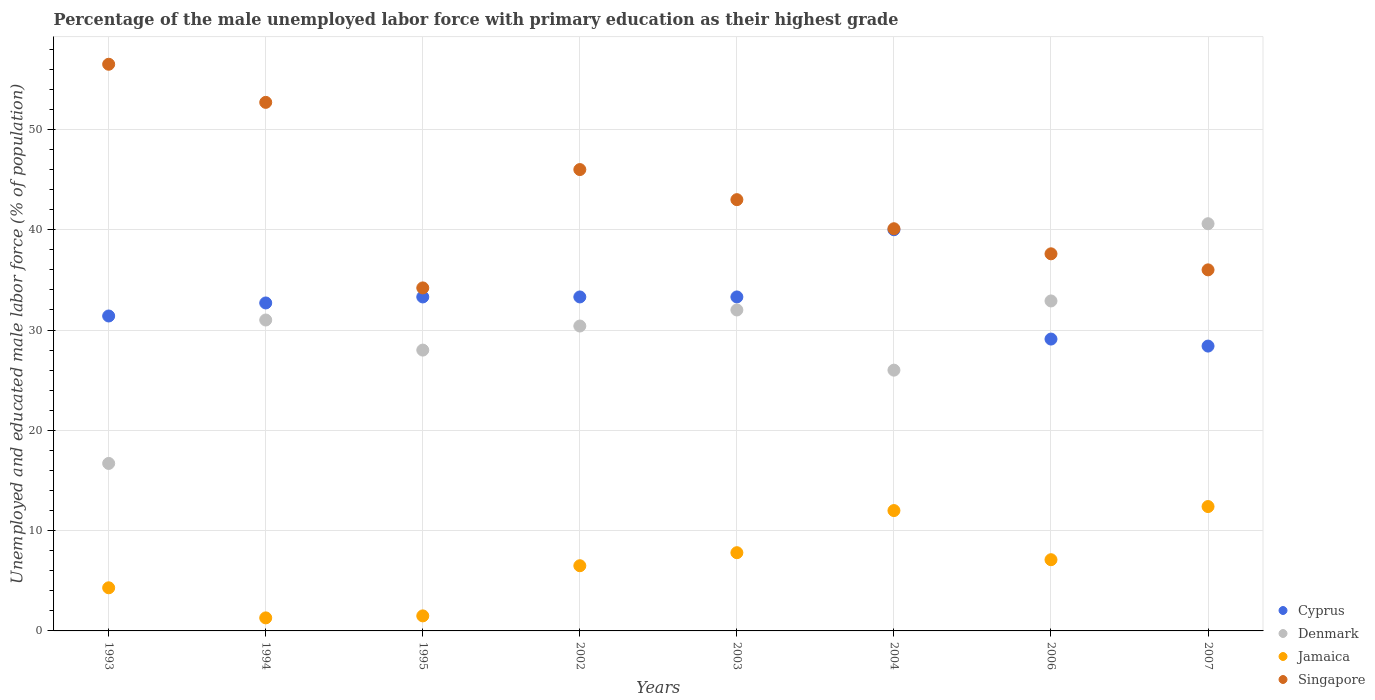How many different coloured dotlines are there?
Provide a succinct answer. 4. What is the percentage of the unemployed male labor force with primary education in Cyprus in 2006?
Your response must be concise. 29.1. Across all years, what is the maximum percentage of the unemployed male labor force with primary education in Cyprus?
Keep it short and to the point. 40. Across all years, what is the minimum percentage of the unemployed male labor force with primary education in Cyprus?
Your response must be concise. 28.4. In which year was the percentage of the unemployed male labor force with primary education in Singapore maximum?
Offer a very short reply. 1993. What is the total percentage of the unemployed male labor force with primary education in Singapore in the graph?
Ensure brevity in your answer.  346.1. What is the difference between the percentage of the unemployed male labor force with primary education in Jamaica in 1994 and that in 2006?
Keep it short and to the point. -5.8. What is the difference between the percentage of the unemployed male labor force with primary education in Jamaica in 2006 and the percentage of the unemployed male labor force with primary education in Singapore in 2004?
Make the answer very short. -33. What is the average percentage of the unemployed male labor force with primary education in Denmark per year?
Your answer should be compact. 29.7. In the year 1993, what is the difference between the percentage of the unemployed male labor force with primary education in Denmark and percentage of the unemployed male labor force with primary education in Cyprus?
Keep it short and to the point. -14.7. What is the ratio of the percentage of the unemployed male labor force with primary education in Denmark in 1995 to that in 2004?
Ensure brevity in your answer.  1.08. What is the difference between the highest and the second highest percentage of the unemployed male labor force with primary education in Cyprus?
Make the answer very short. 6.7. What is the difference between the highest and the lowest percentage of the unemployed male labor force with primary education in Denmark?
Provide a succinct answer. 23.9. Is the sum of the percentage of the unemployed male labor force with primary education in Denmark in 2002 and 2003 greater than the maximum percentage of the unemployed male labor force with primary education in Cyprus across all years?
Provide a short and direct response. Yes. Is it the case that in every year, the sum of the percentage of the unemployed male labor force with primary education in Jamaica and percentage of the unemployed male labor force with primary education in Denmark  is greater than the sum of percentage of the unemployed male labor force with primary education in Singapore and percentage of the unemployed male labor force with primary education in Cyprus?
Your answer should be compact. No. Is the percentage of the unemployed male labor force with primary education in Cyprus strictly less than the percentage of the unemployed male labor force with primary education in Denmark over the years?
Offer a very short reply. No. How many years are there in the graph?
Your answer should be compact. 8. Are the values on the major ticks of Y-axis written in scientific E-notation?
Provide a succinct answer. No. Does the graph contain any zero values?
Your answer should be compact. No. Does the graph contain grids?
Your answer should be compact. Yes. How many legend labels are there?
Offer a very short reply. 4. How are the legend labels stacked?
Provide a short and direct response. Vertical. What is the title of the graph?
Keep it short and to the point. Percentage of the male unemployed labor force with primary education as their highest grade. What is the label or title of the Y-axis?
Ensure brevity in your answer.  Unemployed and educated male labor force (% of population). What is the Unemployed and educated male labor force (% of population) of Cyprus in 1993?
Make the answer very short. 31.4. What is the Unemployed and educated male labor force (% of population) of Denmark in 1993?
Your response must be concise. 16.7. What is the Unemployed and educated male labor force (% of population) in Jamaica in 1993?
Offer a terse response. 4.3. What is the Unemployed and educated male labor force (% of population) in Singapore in 1993?
Keep it short and to the point. 56.5. What is the Unemployed and educated male labor force (% of population) in Cyprus in 1994?
Offer a very short reply. 32.7. What is the Unemployed and educated male labor force (% of population) of Jamaica in 1994?
Make the answer very short. 1.3. What is the Unemployed and educated male labor force (% of population) in Singapore in 1994?
Your response must be concise. 52.7. What is the Unemployed and educated male labor force (% of population) in Cyprus in 1995?
Give a very brief answer. 33.3. What is the Unemployed and educated male labor force (% of population) in Denmark in 1995?
Offer a very short reply. 28. What is the Unemployed and educated male labor force (% of population) of Singapore in 1995?
Provide a succinct answer. 34.2. What is the Unemployed and educated male labor force (% of population) of Cyprus in 2002?
Give a very brief answer. 33.3. What is the Unemployed and educated male labor force (% of population) of Denmark in 2002?
Offer a very short reply. 30.4. What is the Unemployed and educated male labor force (% of population) of Cyprus in 2003?
Make the answer very short. 33.3. What is the Unemployed and educated male labor force (% of population) in Jamaica in 2003?
Keep it short and to the point. 7.8. What is the Unemployed and educated male labor force (% of population) of Singapore in 2004?
Offer a terse response. 40.1. What is the Unemployed and educated male labor force (% of population) in Cyprus in 2006?
Your response must be concise. 29.1. What is the Unemployed and educated male labor force (% of population) in Denmark in 2006?
Provide a short and direct response. 32.9. What is the Unemployed and educated male labor force (% of population) of Jamaica in 2006?
Make the answer very short. 7.1. What is the Unemployed and educated male labor force (% of population) in Singapore in 2006?
Ensure brevity in your answer.  37.6. What is the Unemployed and educated male labor force (% of population) of Cyprus in 2007?
Ensure brevity in your answer.  28.4. What is the Unemployed and educated male labor force (% of population) of Denmark in 2007?
Keep it short and to the point. 40.6. What is the Unemployed and educated male labor force (% of population) in Jamaica in 2007?
Ensure brevity in your answer.  12.4. Across all years, what is the maximum Unemployed and educated male labor force (% of population) of Cyprus?
Give a very brief answer. 40. Across all years, what is the maximum Unemployed and educated male labor force (% of population) of Denmark?
Make the answer very short. 40.6. Across all years, what is the maximum Unemployed and educated male labor force (% of population) of Jamaica?
Offer a very short reply. 12.4. Across all years, what is the maximum Unemployed and educated male labor force (% of population) in Singapore?
Your answer should be very brief. 56.5. Across all years, what is the minimum Unemployed and educated male labor force (% of population) of Cyprus?
Your answer should be very brief. 28.4. Across all years, what is the minimum Unemployed and educated male labor force (% of population) in Denmark?
Keep it short and to the point. 16.7. Across all years, what is the minimum Unemployed and educated male labor force (% of population) of Jamaica?
Offer a terse response. 1.3. Across all years, what is the minimum Unemployed and educated male labor force (% of population) of Singapore?
Your answer should be very brief. 34.2. What is the total Unemployed and educated male labor force (% of population) in Cyprus in the graph?
Offer a terse response. 261.5. What is the total Unemployed and educated male labor force (% of population) in Denmark in the graph?
Offer a terse response. 237.6. What is the total Unemployed and educated male labor force (% of population) of Jamaica in the graph?
Keep it short and to the point. 52.9. What is the total Unemployed and educated male labor force (% of population) of Singapore in the graph?
Offer a very short reply. 346.1. What is the difference between the Unemployed and educated male labor force (% of population) of Denmark in 1993 and that in 1994?
Your answer should be very brief. -14.3. What is the difference between the Unemployed and educated male labor force (% of population) in Jamaica in 1993 and that in 1994?
Your response must be concise. 3. What is the difference between the Unemployed and educated male labor force (% of population) of Cyprus in 1993 and that in 1995?
Give a very brief answer. -1.9. What is the difference between the Unemployed and educated male labor force (% of population) of Singapore in 1993 and that in 1995?
Keep it short and to the point. 22.3. What is the difference between the Unemployed and educated male labor force (% of population) of Cyprus in 1993 and that in 2002?
Ensure brevity in your answer.  -1.9. What is the difference between the Unemployed and educated male labor force (% of population) of Denmark in 1993 and that in 2002?
Provide a short and direct response. -13.7. What is the difference between the Unemployed and educated male labor force (% of population) in Cyprus in 1993 and that in 2003?
Make the answer very short. -1.9. What is the difference between the Unemployed and educated male labor force (% of population) in Denmark in 1993 and that in 2003?
Your response must be concise. -15.3. What is the difference between the Unemployed and educated male labor force (% of population) in Jamaica in 1993 and that in 2003?
Offer a very short reply. -3.5. What is the difference between the Unemployed and educated male labor force (% of population) in Denmark in 1993 and that in 2006?
Keep it short and to the point. -16.2. What is the difference between the Unemployed and educated male labor force (% of population) of Jamaica in 1993 and that in 2006?
Your answer should be compact. -2.8. What is the difference between the Unemployed and educated male labor force (% of population) of Denmark in 1993 and that in 2007?
Provide a succinct answer. -23.9. What is the difference between the Unemployed and educated male labor force (% of population) of Jamaica in 1993 and that in 2007?
Ensure brevity in your answer.  -8.1. What is the difference between the Unemployed and educated male labor force (% of population) of Singapore in 1993 and that in 2007?
Your answer should be compact. 20.5. What is the difference between the Unemployed and educated male labor force (% of population) in Denmark in 1994 and that in 1995?
Ensure brevity in your answer.  3. What is the difference between the Unemployed and educated male labor force (% of population) in Singapore in 1994 and that in 1995?
Your answer should be compact. 18.5. What is the difference between the Unemployed and educated male labor force (% of population) of Cyprus in 1994 and that in 2002?
Your response must be concise. -0.6. What is the difference between the Unemployed and educated male labor force (% of population) in Jamaica in 1994 and that in 2002?
Ensure brevity in your answer.  -5.2. What is the difference between the Unemployed and educated male labor force (% of population) in Denmark in 1994 and that in 2003?
Your response must be concise. -1. What is the difference between the Unemployed and educated male labor force (% of population) of Cyprus in 1994 and that in 2004?
Offer a terse response. -7.3. What is the difference between the Unemployed and educated male labor force (% of population) of Denmark in 1994 and that in 2006?
Make the answer very short. -1.9. What is the difference between the Unemployed and educated male labor force (% of population) in Jamaica in 1994 and that in 2006?
Ensure brevity in your answer.  -5.8. What is the difference between the Unemployed and educated male labor force (% of population) in Cyprus in 1994 and that in 2007?
Provide a short and direct response. 4.3. What is the difference between the Unemployed and educated male labor force (% of population) in Denmark in 1994 and that in 2007?
Offer a very short reply. -9.6. What is the difference between the Unemployed and educated male labor force (% of population) of Jamaica in 1994 and that in 2007?
Offer a very short reply. -11.1. What is the difference between the Unemployed and educated male labor force (% of population) in Denmark in 1995 and that in 2002?
Your response must be concise. -2.4. What is the difference between the Unemployed and educated male labor force (% of population) in Singapore in 1995 and that in 2002?
Ensure brevity in your answer.  -11.8. What is the difference between the Unemployed and educated male labor force (% of population) of Denmark in 1995 and that in 2003?
Offer a terse response. -4. What is the difference between the Unemployed and educated male labor force (% of population) in Singapore in 1995 and that in 2003?
Keep it short and to the point. -8.8. What is the difference between the Unemployed and educated male labor force (% of population) of Cyprus in 1995 and that in 2006?
Your response must be concise. 4.2. What is the difference between the Unemployed and educated male labor force (% of population) of Denmark in 1995 and that in 2006?
Your response must be concise. -4.9. What is the difference between the Unemployed and educated male labor force (% of population) of Jamaica in 1995 and that in 2006?
Your answer should be very brief. -5.6. What is the difference between the Unemployed and educated male labor force (% of population) of Singapore in 1995 and that in 2006?
Offer a terse response. -3.4. What is the difference between the Unemployed and educated male labor force (% of population) in Jamaica in 1995 and that in 2007?
Offer a terse response. -10.9. What is the difference between the Unemployed and educated male labor force (% of population) in Singapore in 1995 and that in 2007?
Your answer should be compact. -1.8. What is the difference between the Unemployed and educated male labor force (% of population) in Denmark in 2002 and that in 2003?
Give a very brief answer. -1.6. What is the difference between the Unemployed and educated male labor force (% of population) of Denmark in 2002 and that in 2004?
Offer a terse response. 4.4. What is the difference between the Unemployed and educated male labor force (% of population) in Jamaica in 2002 and that in 2004?
Your answer should be very brief. -5.5. What is the difference between the Unemployed and educated male labor force (% of population) in Singapore in 2002 and that in 2004?
Offer a very short reply. 5.9. What is the difference between the Unemployed and educated male labor force (% of population) in Singapore in 2002 and that in 2006?
Give a very brief answer. 8.4. What is the difference between the Unemployed and educated male labor force (% of population) in Jamaica in 2002 and that in 2007?
Ensure brevity in your answer.  -5.9. What is the difference between the Unemployed and educated male labor force (% of population) of Singapore in 2002 and that in 2007?
Provide a short and direct response. 10. What is the difference between the Unemployed and educated male labor force (% of population) in Cyprus in 2003 and that in 2004?
Keep it short and to the point. -6.7. What is the difference between the Unemployed and educated male labor force (% of population) of Denmark in 2003 and that in 2004?
Your answer should be very brief. 6. What is the difference between the Unemployed and educated male labor force (% of population) of Jamaica in 2003 and that in 2004?
Your response must be concise. -4.2. What is the difference between the Unemployed and educated male labor force (% of population) of Denmark in 2003 and that in 2006?
Your response must be concise. -0.9. What is the difference between the Unemployed and educated male labor force (% of population) in Jamaica in 2003 and that in 2006?
Offer a terse response. 0.7. What is the difference between the Unemployed and educated male labor force (% of population) in Singapore in 2003 and that in 2006?
Give a very brief answer. 5.4. What is the difference between the Unemployed and educated male labor force (% of population) of Cyprus in 2003 and that in 2007?
Your answer should be compact. 4.9. What is the difference between the Unemployed and educated male labor force (% of population) of Jamaica in 2003 and that in 2007?
Make the answer very short. -4.6. What is the difference between the Unemployed and educated male labor force (% of population) of Singapore in 2003 and that in 2007?
Your response must be concise. 7. What is the difference between the Unemployed and educated male labor force (% of population) in Jamaica in 2004 and that in 2006?
Provide a short and direct response. 4.9. What is the difference between the Unemployed and educated male labor force (% of population) of Singapore in 2004 and that in 2006?
Provide a short and direct response. 2.5. What is the difference between the Unemployed and educated male labor force (% of population) of Cyprus in 2004 and that in 2007?
Your answer should be compact. 11.6. What is the difference between the Unemployed and educated male labor force (% of population) of Denmark in 2004 and that in 2007?
Your answer should be very brief. -14.6. What is the difference between the Unemployed and educated male labor force (% of population) in Singapore in 2004 and that in 2007?
Your response must be concise. 4.1. What is the difference between the Unemployed and educated male labor force (% of population) in Cyprus in 2006 and that in 2007?
Offer a very short reply. 0.7. What is the difference between the Unemployed and educated male labor force (% of population) in Denmark in 2006 and that in 2007?
Offer a terse response. -7.7. What is the difference between the Unemployed and educated male labor force (% of population) of Jamaica in 2006 and that in 2007?
Provide a short and direct response. -5.3. What is the difference between the Unemployed and educated male labor force (% of population) in Singapore in 2006 and that in 2007?
Provide a short and direct response. 1.6. What is the difference between the Unemployed and educated male labor force (% of population) in Cyprus in 1993 and the Unemployed and educated male labor force (% of population) in Jamaica in 1994?
Provide a succinct answer. 30.1. What is the difference between the Unemployed and educated male labor force (% of population) in Cyprus in 1993 and the Unemployed and educated male labor force (% of population) in Singapore in 1994?
Provide a succinct answer. -21.3. What is the difference between the Unemployed and educated male labor force (% of population) in Denmark in 1993 and the Unemployed and educated male labor force (% of population) in Singapore in 1994?
Give a very brief answer. -36. What is the difference between the Unemployed and educated male labor force (% of population) in Jamaica in 1993 and the Unemployed and educated male labor force (% of population) in Singapore in 1994?
Keep it short and to the point. -48.4. What is the difference between the Unemployed and educated male labor force (% of population) of Cyprus in 1993 and the Unemployed and educated male labor force (% of population) of Jamaica in 1995?
Your response must be concise. 29.9. What is the difference between the Unemployed and educated male labor force (% of population) in Cyprus in 1993 and the Unemployed and educated male labor force (% of population) in Singapore in 1995?
Make the answer very short. -2.8. What is the difference between the Unemployed and educated male labor force (% of population) in Denmark in 1993 and the Unemployed and educated male labor force (% of population) in Singapore in 1995?
Offer a very short reply. -17.5. What is the difference between the Unemployed and educated male labor force (% of population) in Jamaica in 1993 and the Unemployed and educated male labor force (% of population) in Singapore in 1995?
Keep it short and to the point. -29.9. What is the difference between the Unemployed and educated male labor force (% of population) of Cyprus in 1993 and the Unemployed and educated male labor force (% of population) of Denmark in 2002?
Keep it short and to the point. 1. What is the difference between the Unemployed and educated male labor force (% of population) in Cyprus in 1993 and the Unemployed and educated male labor force (% of population) in Jamaica in 2002?
Provide a succinct answer. 24.9. What is the difference between the Unemployed and educated male labor force (% of population) of Cyprus in 1993 and the Unemployed and educated male labor force (% of population) of Singapore in 2002?
Offer a very short reply. -14.6. What is the difference between the Unemployed and educated male labor force (% of population) in Denmark in 1993 and the Unemployed and educated male labor force (% of population) in Singapore in 2002?
Your answer should be compact. -29.3. What is the difference between the Unemployed and educated male labor force (% of population) of Jamaica in 1993 and the Unemployed and educated male labor force (% of population) of Singapore in 2002?
Give a very brief answer. -41.7. What is the difference between the Unemployed and educated male labor force (% of population) of Cyprus in 1993 and the Unemployed and educated male labor force (% of population) of Denmark in 2003?
Make the answer very short. -0.6. What is the difference between the Unemployed and educated male labor force (% of population) in Cyprus in 1993 and the Unemployed and educated male labor force (% of population) in Jamaica in 2003?
Ensure brevity in your answer.  23.6. What is the difference between the Unemployed and educated male labor force (% of population) of Denmark in 1993 and the Unemployed and educated male labor force (% of population) of Jamaica in 2003?
Your response must be concise. 8.9. What is the difference between the Unemployed and educated male labor force (% of population) in Denmark in 1993 and the Unemployed and educated male labor force (% of population) in Singapore in 2003?
Your response must be concise. -26.3. What is the difference between the Unemployed and educated male labor force (% of population) in Jamaica in 1993 and the Unemployed and educated male labor force (% of population) in Singapore in 2003?
Ensure brevity in your answer.  -38.7. What is the difference between the Unemployed and educated male labor force (% of population) in Cyprus in 1993 and the Unemployed and educated male labor force (% of population) in Denmark in 2004?
Keep it short and to the point. 5.4. What is the difference between the Unemployed and educated male labor force (% of population) of Cyprus in 1993 and the Unemployed and educated male labor force (% of population) of Jamaica in 2004?
Offer a terse response. 19.4. What is the difference between the Unemployed and educated male labor force (% of population) of Denmark in 1993 and the Unemployed and educated male labor force (% of population) of Singapore in 2004?
Your answer should be very brief. -23.4. What is the difference between the Unemployed and educated male labor force (% of population) of Jamaica in 1993 and the Unemployed and educated male labor force (% of population) of Singapore in 2004?
Your answer should be very brief. -35.8. What is the difference between the Unemployed and educated male labor force (% of population) in Cyprus in 1993 and the Unemployed and educated male labor force (% of population) in Denmark in 2006?
Keep it short and to the point. -1.5. What is the difference between the Unemployed and educated male labor force (% of population) in Cyprus in 1993 and the Unemployed and educated male labor force (% of population) in Jamaica in 2006?
Your answer should be very brief. 24.3. What is the difference between the Unemployed and educated male labor force (% of population) of Cyprus in 1993 and the Unemployed and educated male labor force (% of population) of Singapore in 2006?
Your answer should be compact. -6.2. What is the difference between the Unemployed and educated male labor force (% of population) of Denmark in 1993 and the Unemployed and educated male labor force (% of population) of Singapore in 2006?
Provide a succinct answer. -20.9. What is the difference between the Unemployed and educated male labor force (% of population) in Jamaica in 1993 and the Unemployed and educated male labor force (% of population) in Singapore in 2006?
Keep it short and to the point. -33.3. What is the difference between the Unemployed and educated male labor force (% of population) in Cyprus in 1993 and the Unemployed and educated male labor force (% of population) in Jamaica in 2007?
Make the answer very short. 19. What is the difference between the Unemployed and educated male labor force (% of population) in Cyprus in 1993 and the Unemployed and educated male labor force (% of population) in Singapore in 2007?
Offer a very short reply. -4.6. What is the difference between the Unemployed and educated male labor force (% of population) in Denmark in 1993 and the Unemployed and educated male labor force (% of population) in Singapore in 2007?
Your response must be concise. -19.3. What is the difference between the Unemployed and educated male labor force (% of population) in Jamaica in 1993 and the Unemployed and educated male labor force (% of population) in Singapore in 2007?
Your response must be concise. -31.7. What is the difference between the Unemployed and educated male labor force (% of population) of Cyprus in 1994 and the Unemployed and educated male labor force (% of population) of Denmark in 1995?
Your answer should be very brief. 4.7. What is the difference between the Unemployed and educated male labor force (% of population) of Cyprus in 1994 and the Unemployed and educated male labor force (% of population) of Jamaica in 1995?
Provide a succinct answer. 31.2. What is the difference between the Unemployed and educated male labor force (% of population) in Denmark in 1994 and the Unemployed and educated male labor force (% of population) in Jamaica in 1995?
Provide a short and direct response. 29.5. What is the difference between the Unemployed and educated male labor force (% of population) in Denmark in 1994 and the Unemployed and educated male labor force (% of population) in Singapore in 1995?
Provide a short and direct response. -3.2. What is the difference between the Unemployed and educated male labor force (% of population) in Jamaica in 1994 and the Unemployed and educated male labor force (% of population) in Singapore in 1995?
Ensure brevity in your answer.  -32.9. What is the difference between the Unemployed and educated male labor force (% of population) of Cyprus in 1994 and the Unemployed and educated male labor force (% of population) of Jamaica in 2002?
Give a very brief answer. 26.2. What is the difference between the Unemployed and educated male labor force (% of population) in Denmark in 1994 and the Unemployed and educated male labor force (% of population) in Singapore in 2002?
Ensure brevity in your answer.  -15. What is the difference between the Unemployed and educated male labor force (% of population) of Jamaica in 1994 and the Unemployed and educated male labor force (% of population) of Singapore in 2002?
Your answer should be very brief. -44.7. What is the difference between the Unemployed and educated male labor force (% of population) in Cyprus in 1994 and the Unemployed and educated male labor force (% of population) in Jamaica in 2003?
Ensure brevity in your answer.  24.9. What is the difference between the Unemployed and educated male labor force (% of population) of Cyprus in 1994 and the Unemployed and educated male labor force (% of population) of Singapore in 2003?
Keep it short and to the point. -10.3. What is the difference between the Unemployed and educated male labor force (% of population) in Denmark in 1994 and the Unemployed and educated male labor force (% of population) in Jamaica in 2003?
Offer a very short reply. 23.2. What is the difference between the Unemployed and educated male labor force (% of population) in Denmark in 1994 and the Unemployed and educated male labor force (% of population) in Singapore in 2003?
Give a very brief answer. -12. What is the difference between the Unemployed and educated male labor force (% of population) in Jamaica in 1994 and the Unemployed and educated male labor force (% of population) in Singapore in 2003?
Your response must be concise. -41.7. What is the difference between the Unemployed and educated male labor force (% of population) of Cyprus in 1994 and the Unemployed and educated male labor force (% of population) of Jamaica in 2004?
Give a very brief answer. 20.7. What is the difference between the Unemployed and educated male labor force (% of population) in Cyprus in 1994 and the Unemployed and educated male labor force (% of population) in Singapore in 2004?
Keep it short and to the point. -7.4. What is the difference between the Unemployed and educated male labor force (% of population) of Denmark in 1994 and the Unemployed and educated male labor force (% of population) of Jamaica in 2004?
Your response must be concise. 19. What is the difference between the Unemployed and educated male labor force (% of population) of Jamaica in 1994 and the Unemployed and educated male labor force (% of population) of Singapore in 2004?
Ensure brevity in your answer.  -38.8. What is the difference between the Unemployed and educated male labor force (% of population) in Cyprus in 1994 and the Unemployed and educated male labor force (% of population) in Denmark in 2006?
Your answer should be compact. -0.2. What is the difference between the Unemployed and educated male labor force (% of population) in Cyprus in 1994 and the Unemployed and educated male labor force (% of population) in Jamaica in 2006?
Offer a very short reply. 25.6. What is the difference between the Unemployed and educated male labor force (% of population) of Denmark in 1994 and the Unemployed and educated male labor force (% of population) of Jamaica in 2006?
Ensure brevity in your answer.  23.9. What is the difference between the Unemployed and educated male labor force (% of population) in Denmark in 1994 and the Unemployed and educated male labor force (% of population) in Singapore in 2006?
Ensure brevity in your answer.  -6.6. What is the difference between the Unemployed and educated male labor force (% of population) in Jamaica in 1994 and the Unemployed and educated male labor force (% of population) in Singapore in 2006?
Provide a succinct answer. -36.3. What is the difference between the Unemployed and educated male labor force (% of population) in Cyprus in 1994 and the Unemployed and educated male labor force (% of population) in Jamaica in 2007?
Give a very brief answer. 20.3. What is the difference between the Unemployed and educated male labor force (% of population) of Cyprus in 1994 and the Unemployed and educated male labor force (% of population) of Singapore in 2007?
Give a very brief answer. -3.3. What is the difference between the Unemployed and educated male labor force (% of population) of Denmark in 1994 and the Unemployed and educated male labor force (% of population) of Singapore in 2007?
Keep it short and to the point. -5. What is the difference between the Unemployed and educated male labor force (% of population) in Jamaica in 1994 and the Unemployed and educated male labor force (% of population) in Singapore in 2007?
Your answer should be very brief. -34.7. What is the difference between the Unemployed and educated male labor force (% of population) in Cyprus in 1995 and the Unemployed and educated male labor force (% of population) in Denmark in 2002?
Offer a very short reply. 2.9. What is the difference between the Unemployed and educated male labor force (% of population) in Cyprus in 1995 and the Unemployed and educated male labor force (% of population) in Jamaica in 2002?
Your answer should be very brief. 26.8. What is the difference between the Unemployed and educated male labor force (% of population) of Denmark in 1995 and the Unemployed and educated male labor force (% of population) of Jamaica in 2002?
Provide a succinct answer. 21.5. What is the difference between the Unemployed and educated male labor force (% of population) of Denmark in 1995 and the Unemployed and educated male labor force (% of population) of Singapore in 2002?
Your response must be concise. -18. What is the difference between the Unemployed and educated male labor force (% of population) of Jamaica in 1995 and the Unemployed and educated male labor force (% of population) of Singapore in 2002?
Ensure brevity in your answer.  -44.5. What is the difference between the Unemployed and educated male labor force (% of population) of Cyprus in 1995 and the Unemployed and educated male labor force (% of population) of Jamaica in 2003?
Your response must be concise. 25.5. What is the difference between the Unemployed and educated male labor force (% of population) in Denmark in 1995 and the Unemployed and educated male labor force (% of population) in Jamaica in 2003?
Give a very brief answer. 20.2. What is the difference between the Unemployed and educated male labor force (% of population) of Jamaica in 1995 and the Unemployed and educated male labor force (% of population) of Singapore in 2003?
Provide a succinct answer. -41.5. What is the difference between the Unemployed and educated male labor force (% of population) of Cyprus in 1995 and the Unemployed and educated male labor force (% of population) of Denmark in 2004?
Provide a succinct answer. 7.3. What is the difference between the Unemployed and educated male labor force (% of population) in Cyprus in 1995 and the Unemployed and educated male labor force (% of population) in Jamaica in 2004?
Your answer should be very brief. 21.3. What is the difference between the Unemployed and educated male labor force (% of population) of Cyprus in 1995 and the Unemployed and educated male labor force (% of population) of Singapore in 2004?
Provide a succinct answer. -6.8. What is the difference between the Unemployed and educated male labor force (% of population) of Denmark in 1995 and the Unemployed and educated male labor force (% of population) of Jamaica in 2004?
Your answer should be compact. 16. What is the difference between the Unemployed and educated male labor force (% of population) of Jamaica in 1995 and the Unemployed and educated male labor force (% of population) of Singapore in 2004?
Provide a short and direct response. -38.6. What is the difference between the Unemployed and educated male labor force (% of population) of Cyprus in 1995 and the Unemployed and educated male labor force (% of population) of Denmark in 2006?
Provide a succinct answer. 0.4. What is the difference between the Unemployed and educated male labor force (% of population) of Cyprus in 1995 and the Unemployed and educated male labor force (% of population) of Jamaica in 2006?
Make the answer very short. 26.2. What is the difference between the Unemployed and educated male labor force (% of population) of Denmark in 1995 and the Unemployed and educated male labor force (% of population) of Jamaica in 2006?
Keep it short and to the point. 20.9. What is the difference between the Unemployed and educated male labor force (% of population) in Jamaica in 1995 and the Unemployed and educated male labor force (% of population) in Singapore in 2006?
Ensure brevity in your answer.  -36.1. What is the difference between the Unemployed and educated male labor force (% of population) of Cyprus in 1995 and the Unemployed and educated male labor force (% of population) of Denmark in 2007?
Your response must be concise. -7.3. What is the difference between the Unemployed and educated male labor force (% of population) in Cyprus in 1995 and the Unemployed and educated male labor force (% of population) in Jamaica in 2007?
Provide a succinct answer. 20.9. What is the difference between the Unemployed and educated male labor force (% of population) in Denmark in 1995 and the Unemployed and educated male labor force (% of population) in Jamaica in 2007?
Provide a succinct answer. 15.6. What is the difference between the Unemployed and educated male labor force (% of population) in Denmark in 1995 and the Unemployed and educated male labor force (% of population) in Singapore in 2007?
Offer a terse response. -8. What is the difference between the Unemployed and educated male labor force (% of population) of Jamaica in 1995 and the Unemployed and educated male labor force (% of population) of Singapore in 2007?
Ensure brevity in your answer.  -34.5. What is the difference between the Unemployed and educated male labor force (% of population) of Cyprus in 2002 and the Unemployed and educated male labor force (% of population) of Jamaica in 2003?
Offer a terse response. 25.5. What is the difference between the Unemployed and educated male labor force (% of population) of Denmark in 2002 and the Unemployed and educated male labor force (% of population) of Jamaica in 2003?
Your answer should be very brief. 22.6. What is the difference between the Unemployed and educated male labor force (% of population) in Jamaica in 2002 and the Unemployed and educated male labor force (% of population) in Singapore in 2003?
Ensure brevity in your answer.  -36.5. What is the difference between the Unemployed and educated male labor force (% of population) in Cyprus in 2002 and the Unemployed and educated male labor force (% of population) in Jamaica in 2004?
Ensure brevity in your answer.  21.3. What is the difference between the Unemployed and educated male labor force (% of population) in Cyprus in 2002 and the Unemployed and educated male labor force (% of population) in Singapore in 2004?
Ensure brevity in your answer.  -6.8. What is the difference between the Unemployed and educated male labor force (% of population) of Denmark in 2002 and the Unemployed and educated male labor force (% of population) of Jamaica in 2004?
Your answer should be compact. 18.4. What is the difference between the Unemployed and educated male labor force (% of population) in Denmark in 2002 and the Unemployed and educated male labor force (% of population) in Singapore in 2004?
Give a very brief answer. -9.7. What is the difference between the Unemployed and educated male labor force (% of population) in Jamaica in 2002 and the Unemployed and educated male labor force (% of population) in Singapore in 2004?
Ensure brevity in your answer.  -33.6. What is the difference between the Unemployed and educated male labor force (% of population) of Cyprus in 2002 and the Unemployed and educated male labor force (% of population) of Denmark in 2006?
Offer a terse response. 0.4. What is the difference between the Unemployed and educated male labor force (% of population) of Cyprus in 2002 and the Unemployed and educated male labor force (% of population) of Jamaica in 2006?
Ensure brevity in your answer.  26.2. What is the difference between the Unemployed and educated male labor force (% of population) in Denmark in 2002 and the Unemployed and educated male labor force (% of population) in Jamaica in 2006?
Offer a terse response. 23.3. What is the difference between the Unemployed and educated male labor force (% of population) of Denmark in 2002 and the Unemployed and educated male labor force (% of population) of Singapore in 2006?
Your answer should be compact. -7.2. What is the difference between the Unemployed and educated male labor force (% of population) in Jamaica in 2002 and the Unemployed and educated male labor force (% of population) in Singapore in 2006?
Ensure brevity in your answer.  -31.1. What is the difference between the Unemployed and educated male labor force (% of population) in Cyprus in 2002 and the Unemployed and educated male labor force (% of population) in Jamaica in 2007?
Your answer should be compact. 20.9. What is the difference between the Unemployed and educated male labor force (% of population) of Denmark in 2002 and the Unemployed and educated male labor force (% of population) of Jamaica in 2007?
Offer a terse response. 18. What is the difference between the Unemployed and educated male labor force (% of population) of Denmark in 2002 and the Unemployed and educated male labor force (% of population) of Singapore in 2007?
Offer a very short reply. -5.6. What is the difference between the Unemployed and educated male labor force (% of population) in Jamaica in 2002 and the Unemployed and educated male labor force (% of population) in Singapore in 2007?
Your answer should be very brief. -29.5. What is the difference between the Unemployed and educated male labor force (% of population) of Cyprus in 2003 and the Unemployed and educated male labor force (% of population) of Denmark in 2004?
Ensure brevity in your answer.  7.3. What is the difference between the Unemployed and educated male labor force (% of population) in Cyprus in 2003 and the Unemployed and educated male labor force (% of population) in Jamaica in 2004?
Offer a very short reply. 21.3. What is the difference between the Unemployed and educated male labor force (% of population) of Jamaica in 2003 and the Unemployed and educated male labor force (% of population) of Singapore in 2004?
Your answer should be compact. -32.3. What is the difference between the Unemployed and educated male labor force (% of population) in Cyprus in 2003 and the Unemployed and educated male labor force (% of population) in Jamaica in 2006?
Provide a succinct answer. 26.2. What is the difference between the Unemployed and educated male labor force (% of population) of Cyprus in 2003 and the Unemployed and educated male labor force (% of population) of Singapore in 2006?
Provide a succinct answer. -4.3. What is the difference between the Unemployed and educated male labor force (% of population) of Denmark in 2003 and the Unemployed and educated male labor force (% of population) of Jamaica in 2006?
Ensure brevity in your answer.  24.9. What is the difference between the Unemployed and educated male labor force (% of population) of Jamaica in 2003 and the Unemployed and educated male labor force (% of population) of Singapore in 2006?
Keep it short and to the point. -29.8. What is the difference between the Unemployed and educated male labor force (% of population) in Cyprus in 2003 and the Unemployed and educated male labor force (% of population) in Jamaica in 2007?
Offer a very short reply. 20.9. What is the difference between the Unemployed and educated male labor force (% of population) in Cyprus in 2003 and the Unemployed and educated male labor force (% of population) in Singapore in 2007?
Provide a succinct answer. -2.7. What is the difference between the Unemployed and educated male labor force (% of population) of Denmark in 2003 and the Unemployed and educated male labor force (% of population) of Jamaica in 2007?
Give a very brief answer. 19.6. What is the difference between the Unemployed and educated male labor force (% of population) of Jamaica in 2003 and the Unemployed and educated male labor force (% of population) of Singapore in 2007?
Your response must be concise. -28.2. What is the difference between the Unemployed and educated male labor force (% of population) in Cyprus in 2004 and the Unemployed and educated male labor force (% of population) in Denmark in 2006?
Make the answer very short. 7.1. What is the difference between the Unemployed and educated male labor force (% of population) of Cyprus in 2004 and the Unemployed and educated male labor force (% of population) of Jamaica in 2006?
Ensure brevity in your answer.  32.9. What is the difference between the Unemployed and educated male labor force (% of population) in Denmark in 2004 and the Unemployed and educated male labor force (% of population) in Singapore in 2006?
Provide a succinct answer. -11.6. What is the difference between the Unemployed and educated male labor force (% of population) of Jamaica in 2004 and the Unemployed and educated male labor force (% of population) of Singapore in 2006?
Make the answer very short. -25.6. What is the difference between the Unemployed and educated male labor force (% of population) in Cyprus in 2004 and the Unemployed and educated male labor force (% of population) in Denmark in 2007?
Your answer should be very brief. -0.6. What is the difference between the Unemployed and educated male labor force (% of population) in Cyprus in 2004 and the Unemployed and educated male labor force (% of population) in Jamaica in 2007?
Offer a very short reply. 27.6. What is the difference between the Unemployed and educated male labor force (% of population) in Denmark in 2004 and the Unemployed and educated male labor force (% of population) in Jamaica in 2007?
Your answer should be compact. 13.6. What is the difference between the Unemployed and educated male labor force (% of population) of Cyprus in 2006 and the Unemployed and educated male labor force (% of population) of Jamaica in 2007?
Offer a very short reply. 16.7. What is the difference between the Unemployed and educated male labor force (% of population) of Cyprus in 2006 and the Unemployed and educated male labor force (% of population) of Singapore in 2007?
Keep it short and to the point. -6.9. What is the difference between the Unemployed and educated male labor force (% of population) of Denmark in 2006 and the Unemployed and educated male labor force (% of population) of Jamaica in 2007?
Offer a very short reply. 20.5. What is the difference between the Unemployed and educated male labor force (% of population) in Denmark in 2006 and the Unemployed and educated male labor force (% of population) in Singapore in 2007?
Ensure brevity in your answer.  -3.1. What is the difference between the Unemployed and educated male labor force (% of population) in Jamaica in 2006 and the Unemployed and educated male labor force (% of population) in Singapore in 2007?
Offer a very short reply. -28.9. What is the average Unemployed and educated male labor force (% of population) in Cyprus per year?
Give a very brief answer. 32.69. What is the average Unemployed and educated male labor force (% of population) of Denmark per year?
Make the answer very short. 29.7. What is the average Unemployed and educated male labor force (% of population) of Jamaica per year?
Your response must be concise. 6.61. What is the average Unemployed and educated male labor force (% of population) of Singapore per year?
Make the answer very short. 43.26. In the year 1993, what is the difference between the Unemployed and educated male labor force (% of population) in Cyprus and Unemployed and educated male labor force (% of population) in Jamaica?
Offer a very short reply. 27.1. In the year 1993, what is the difference between the Unemployed and educated male labor force (% of population) of Cyprus and Unemployed and educated male labor force (% of population) of Singapore?
Ensure brevity in your answer.  -25.1. In the year 1993, what is the difference between the Unemployed and educated male labor force (% of population) of Denmark and Unemployed and educated male labor force (% of population) of Jamaica?
Your answer should be compact. 12.4. In the year 1993, what is the difference between the Unemployed and educated male labor force (% of population) in Denmark and Unemployed and educated male labor force (% of population) in Singapore?
Offer a very short reply. -39.8. In the year 1993, what is the difference between the Unemployed and educated male labor force (% of population) in Jamaica and Unemployed and educated male labor force (% of population) in Singapore?
Keep it short and to the point. -52.2. In the year 1994, what is the difference between the Unemployed and educated male labor force (% of population) of Cyprus and Unemployed and educated male labor force (% of population) of Denmark?
Your answer should be very brief. 1.7. In the year 1994, what is the difference between the Unemployed and educated male labor force (% of population) of Cyprus and Unemployed and educated male labor force (% of population) of Jamaica?
Ensure brevity in your answer.  31.4. In the year 1994, what is the difference between the Unemployed and educated male labor force (% of population) in Denmark and Unemployed and educated male labor force (% of population) in Jamaica?
Provide a succinct answer. 29.7. In the year 1994, what is the difference between the Unemployed and educated male labor force (% of population) of Denmark and Unemployed and educated male labor force (% of population) of Singapore?
Provide a succinct answer. -21.7. In the year 1994, what is the difference between the Unemployed and educated male labor force (% of population) in Jamaica and Unemployed and educated male labor force (% of population) in Singapore?
Your response must be concise. -51.4. In the year 1995, what is the difference between the Unemployed and educated male labor force (% of population) of Cyprus and Unemployed and educated male labor force (% of population) of Jamaica?
Offer a terse response. 31.8. In the year 1995, what is the difference between the Unemployed and educated male labor force (% of population) in Cyprus and Unemployed and educated male labor force (% of population) in Singapore?
Your answer should be very brief. -0.9. In the year 1995, what is the difference between the Unemployed and educated male labor force (% of population) of Denmark and Unemployed and educated male labor force (% of population) of Jamaica?
Offer a very short reply. 26.5. In the year 1995, what is the difference between the Unemployed and educated male labor force (% of population) in Denmark and Unemployed and educated male labor force (% of population) in Singapore?
Offer a very short reply. -6.2. In the year 1995, what is the difference between the Unemployed and educated male labor force (% of population) in Jamaica and Unemployed and educated male labor force (% of population) in Singapore?
Your answer should be compact. -32.7. In the year 2002, what is the difference between the Unemployed and educated male labor force (% of population) in Cyprus and Unemployed and educated male labor force (% of population) in Denmark?
Your answer should be compact. 2.9. In the year 2002, what is the difference between the Unemployed and educated male labor force (% of population) of Cyprus and Unemployed and educated male labor force (% of population) of Jamaica?
Make the answer very short. 26.8. In the year 2002, what is the difference between the Unemployed and educated male labor force (% of population) in Cyprus and Unemployed and educated male labor force (% of population) in Singapore?
Provide a short and direct response. -12.7. In the year 2002, what is the difference between the Unemployed and educated male labor force (% of population) of Denmark and Unemployed and educated male labor force (% of population) of Jamaica?
Offer a very short reply. 23.9. In the year 2002, what is the difference between the Unemployed and educated male labor force (% of population) of Denmark and Unemployed and educated male labor force (% of population) of Singapore?
Make the answer very short. -15.6. In the year 2002, what is the difference between the Unemployed and educated male labor force (% of population) of Jamaica and Unemployed and educated male labor force (% of population) of Singapore?
Keep it short and to the point. -39.5. In the year 2003, what is the difference between the Unemployed and educated male labor force (% of population) in Cyprus and Unemployed and educated male labor force (% of population) in Denmark?
Your answer should be compact. 1.3. In the year 2003, what is the difference between the Unemployed and educated male labor force (% of population) in Cyprus and Unemployed and educated male labor force (% of population) in Jamaica?
Your answer should be compact. 25.5. In the year 2003, what is the difference between the Unemployed and educated male labor force (% of population) in Denmark and Unemployed and educated male labor force (% of population) in Jamaica?
Offer a very short reply. 24.2. In the year 2003, what is the difference between the Unemployed and educated male labor force (% of population) of Jamaica and Unemployed and educated male labor force (% of population) of Singapore?
Ensure brevity in your answer.  -35.2. In the year 2004, what is the difference between the Unemployed and educated male labor force (% of population) in Cyprus and Unemployed and educated male labor force (% of population) in Singapore?
Offer a terse response. -0.1. In the year 2004, what is the difference between the Unemployed and educated male labor force (% of population) in Denmark and Unemployed and educated male labor force (% of population) in Jamaica?
Offer a terse response. 14. In the year 2004, what is the difference between the Unemployed and educated male labor force (% of population) of Denmark and Unemployed and educated male labor force (% of population) of Singapore?
Your answer should be very brief. -14.1. In the year 2004, what is the difference between the Unemployed and educated male labor force (% of population) of Jamaica and Unemployed and educated male labor force (% of population) of Singapore?
Make the answer very short. -28.1. In the year 2006, what is the difference between the Unemployed and educated male labor force (% of population) in Cyprus and Unemployed and educated male labor force (% of population) in Denmark?
Your answer should be compact. -3.8. In the year 2006, what is the difference between the Unemployed and educated male labor force (% of population) of Cyprus and Unemployed and educated male labor force (% of population) of Singapore?
Offer a very short reply. -8.5. In the year 2006, what is the difference between the Unemployed and educated male labor force (% of population) of Denmark and Unemployed and educated male labor force (% of population) of Jamaica?
Provide a short and direct response. 25.8. In the year 2006, what is the difference between the Unemployed and educated male labor force (% of population) in Denmark and Unemployed and educated male labor force (% of population) in Singapore?
Provide a short and direct response. -4.7. In the year 2006, what is the difference between the Unemployed and educated male labor force (% of population) in Jamaica and Unemployed and educated male labor force (% of population) in Singapore?
Your answer should be very brief. -30.5. In the year 2007, what is the difference between the Unemployed and educated male labor force (% of population) of Cyprus and Unemployed and educated male labor force (% of population) of Jamaica?
Make the answer very short. 16. In the year 2007, what is the difference between the Unemployed and educated male labor force (% of population) of Denmark and Unemployed and educated male labor force (% of population) of Jamaica?
Keep it short and to the point. 28.2. In the year 2007, what is the difference between the Unemployed and educated male labor force (% of population) in Jamaica and Unemployed and educated male labor force (% of population) in Singapore?
Your response must be concise. -23.6. What is the ratio of the Unemployed and educated male labor force (% of population) of Cyprus in 1993 to that in 1994?
Give a very brief answer. 0.96. What is the ratio of the Unemployed and educated male labor force (% of population) in Denmark in 1993 to that in 1994?
Keep it short and to the point. 0.54. What is the ratio of the Unemployed and educated male labor force (% of population) in Jamaica in 1993 to that in 1994?
Keep it short and to the point. 3.31. What is the ratio of the Unemployed and educated male labor force (% of population) of Singapore in 1993 to that in 1994?
Make the answer very short. 1.07. What is the ratio of the Unemployed and educated male labor force (% of population) in Cyprus in 1993 to that in 1995?
Provide a succinct answer. 0.94. What is the ratio of the Unemployed and educated male labor force (% of population) of Denmark in 1993 to that in 1995?
Give a very brief answer. 0.6. What is the ratio of the Unemployed and educated male labor force (% of population) of Jamaica in 1993 to that in 1995?
Ensure brevity in your answer.  2.87. What is the ratio of the Unemployed and educated male labor force (% of population) in Singapore in 1993 to that in 1995?
Your response must be concise. 1.65. What is the ratio of the Unemployed and educated male labor force (% of population) of Cyprus in 1993 to that in 2002?
Your answer should be very brief. 0.94. What is the ratio of the Unemployed and educated male labor force (% of population) of Denmark in 1993 to that in 2002?
Give a very brief answer. 0.55. What is the ratio of the Unemployed and educated male labor force (% of population) of Jamaica in 1993 to that in 2002?
Offer a very short reply. 0.66. What is the ratio of the Unemployed and educated male labor force (% of population) in Singapore in 1993 to that in 2002?
Your answer should be compact. 1.23. What is the ratio of the Unemployed and educated male labor force (% of population) of Cyprus in 1993 to that in 2003?
Provide a short and direct response. 0.94. What is the ratio of the Unemployed and educated male labor force (% of population) in Denmark in 1993 to that in 2003?
Make the answer very short. 0.52. What is the ratio of the Unemployed and educated male labor force (% of population) in Jamaica in 1993 to that in 2003?
Make the answer very short. 0.55. What is the ratio of the Unemployed and educated male labor force (% of population) of Singapore in 1993 to that in 2003?
Provide a short and direct response. 1.31. What is the ratio of the Unemployed and educated male labor force (% of population) in Cyprus in 1993 to that in 2004?
Your answer should be very brief. 0.79. What is the ratio of the Unemployed and educated male labor force (% of population) in Denmark in 1993 to that in 2004?
Make the answer very short. 0.64. What is the ratio of the Unemployed and educated male labor force (% of population) of Jamaica in 1993 to that in 2004?
Your answer should be very brief. 0.36. What is the ratio of the Unemployed and educated male labor force (% of population) in Singapore in 1993 to that in 2004?
Your response must be concise. 1.41. What is the ratio of the Unemployed and educated male labor force (% of population) of Cyprus in 1993 to that in 2006?
Keep it short and to the point. 1.08. What is the ratio of the Unemployed and educated male labor force (% of population) in Denmark in 1993 to that in 2006?
Keep it short and to the point. 0.51. What is the ratio of the Unemployed and educated male labor force (% of population) of Jamaica in 1993 to that in 2006?
Ensure brevity in your answer.  0.61. What is the ratio of the Unemployed and educated male labor force (% of population) in Singapore in 1993 to that in 2006?
Provide a short and direct response. 1.5. What is the ratio of the Unemployed and educated male labor force (% of population) in Cyprus in 1993 to that in 2007?
Provide a succinct answer. 1.11. What is the ratio of the Unemployed and educated male labor force (% of population) in Denmark in 1993 to that in 2007?
Keep it short and to the point. 0.41. What is the ratio of the Unemployed and educated male labor force (% of population) of Jamaica in 1993 to that in 2007?
Provide a succinct answer. 0.35. What is the ratio of the Unemployed and educated male labor force (% of population) of Singapore in 1993 to that in 2007?
Provide a succinct answer. 1.57. What is the ratio of the Unemployed and educated male labor force (% of population) in Denmark in 1994 to that in 1995?
Make the answer very short. 1.11. What is the ratio of the Unemployed and educated male labor force (% of population) in Jamaica in 1994 to that in 1995?
Offer a terse response. 0.87. What is the ratio of the Unemployed and educated male labor force (% of population) in Singapore in 1994 to that in 1995?
Your answer should be compact. 1.54. What is the ratio of the Unemployed and educated male labor force (% of population) of Denmark in 1994 to that in 2002?
Your answer should be compact. 1.02. What is the ratio of the Unemployed and educated male labor force (% of population) in Jamaica in 1994 to that in 2002?
Your answer should be very brief. 0.2. What is the ratio of the Unemployed and educated male labor force (% of population) of Singapore in 1994 to that in 2002?
Offer a very short reply. 1.15. What is the ratio of the Unemployed and educated male labor force (% of population) in Cyprus in 1994 to that in 2003?
Make the answer very short. 0.98. What is the ratio of the Unemployed and educated male labor force (% of population) of Denmark in 1994 to that in 2003?
Provide a succinct answer. 0.97. What is the ratio of the Unemployed and educated male labor force (% of population) of Jamaica in 1994 to that in 2003?
Your response must be concise. 0.17. What is the ratio of the Unemployed and educated male labor force (% of population) in Singapore in 1994 to that in 2003?
Ensure brevity in your answer.  1.23. What is the ratio of the Unemployed and educated male labor force (% of population) of Cyprus in 1994 to that in 2004?
Make the answer very short. 0.82. What is the ratio of the Unemployed and educated male labor force (% of population) of Denmark in 1994 to that in 2004?
Your answer should be very brief. 1.19. What is the ratio of the Unemployed and educated male labor force (% of population) of Jamaica in 1994 to that in 2004?
Your response must be concise. 0.11. What is the ratio of the Unemployed and educated male labor force (% of population) in Singapore in 1994 to that in 2004?
Provide a succinct answer. 1.31. What is the ratio of the Unemployed and educated male labor force (% of population) of Cyprus in 1994 to that in 2006?
Offer a very short reply. 1.12. What is the ratio of the Unemployed and educated male labor force (% of population) of Denmark in 1994 to that in 2006?
Your answer should be compact. 0.94. What is the ratio of the Unemployed and educated male labor force (% of population) of Jamaica in 1994 to that in 2006?
Your response must be concise. 0.18. What is the ratio of the Unemployed and educated male labor force (% of population) of Singapore in 1994 to that in 2006?
Your answer should be compact. 1.4. What is the ratio of the Unemployed and educated male labor force (% of population) in Cyprus in 1994 to that in 2007?
Your answer should be compact. 1.15. What is the ratio of the Unemployed and educated male labor force (% of population) of Denmark in 1994 to that in 2007?
Your answer should be compact. 0.76. What is the ratio of the Unemployed and educated male labor force (% of population) of Jamaica in 1994 to that in 2007?
Offer a very short reply. 0.1. What is the ratio of the Unemployed and educated male labor force (% of population) of Singapore in 1994 to that in 2007?
Keep it short and to the point. 1.46. What is the ratio of the Unemployed and educated male labor force (% of population) of Denmark in 1995 to that in 2002?
Offer a very short reply. 0.92. What is the ratio of the Unemployed and educated male labor force (% of population) in Jamaica in 1995 to that in 2002?
Give a very brief answer. 0.23. What is the ratio of the Unemployed and educated male labor force (% of population) of Singapore in 1995 to that in 2002?
Provide a short and direct response. 0.74. What is the ratio of the Unemployed and educated male labor force (% of population) of Denmark in 1995 to that in 2003?
Provide a succinct answer. 0.88. What is the ratio of the Unemployed and educated male labor force (% of population) of Jamaica in 1995 to that in 2003?
Offer a terse response. 0.19. What is the ratio of the Unemployed and educated male labor force (% of population) in Singapore in 1995 to that in 2003?
Make the answer very short. 0.8. What is the ratio of the Unemployed and educated male labor force (% of population) in Cyprus in 1995 to that in 2004?
Offer a terse response. 0.83. What is the ratio of the Unemployed and educated male labor force (% of population) of Jamaica in 1995 to that in 2004?
Provide a succinct answer. 0.12. What is the ratio of the Unemployed and educated male labor force (% of population) of Singapore in 1995 to that in 2004?
Make the answer very short. 0.85. What is the ratio of the Unemployed and educated male labor force (% of population) in Cyprus in 1995 to that in 2006?
Offer a terse response. 1.14. What is the ratio of the Unemployed and educated male labor force (% of population) in Denmark in 1995 to that in 2006?
Provide a short and direct response. 0.85. What is the ratio of the Unemployed and educated male labor force (% of population) of Jamaica in 1995 to that in 2006?
Keep it short and to the point. 0.21. What is the ratio of the Unemployed and educated male labor force (% of population) of Singapore in 1995 to that in 2006?
Make the answer very short. 0.91. What is the ratio of the Unemployed and educated male labor force (% of population) of Cyprus in 1995 to that in 2007?
Keep it short and to the point. 1.17. What is the ratio of the Unemployed and educated male labor force (% of population) of Denmark in 1995 to that in 2007?
Offer a terse response. 0.69. What is the ratio of the Unemployed and educated male labor force (% of population) of Jamaica in 1995 to that in 2007?
Offer a terse response. 0.12. What is the ratio of the Unemployed and educated male labor force (% of population) of Singapore in 1995 to that in 2007?
Provide a short and direct response. 0.95. What is the ratio of the Unemployed and educated male labor force (% of population) in Cyprus in 2002 to that in 2003?
Ensure brevity in your answer.  1. What is the ratio of the Unemployed and educated male labor force (% of population) of Singapore in 2002 to that in 2003?
Your response must be concise. 1.07. What is the ratio of the Unemployed and educated male labor force (% of population) of Cyprus in 2002 to that in 2004?
Make the answer very short. 0.83. What is the ratio of the Unemployed and educated male labor force (% of population) of Denmark in 2002 to that in 2004?
Keep it short and to the point. 1.17. What is the ratio of the Unemployed and educated male labor force (% of population) of Jamaica in 2002 to that in 2004?
Your answer should be very brief. 0.54. What is the ratio of the Unemployed and educated male labor force (% of population) of Singapore in 2002 to that in 2004?
Your answer should be very brief. 1.15. What is the ratio of the Unemployed and educated male labor force (% of population) in Cyprus in 2002 to that in 2006?
Make the answer very short. 1.14. What is the ratio of the Unemployed and educated male labor force (% of population) of Denmark in 2002 to that in 2006?
Your answer should be compact. 0.92. What is the ratio of the Unemployed and educated male labor force (% of population) in Jamaica in 2002 to that in 2006?
Provide a succinct answer. 0.92. What is the ratio of the Unemployed and educated male labor force (% of population) in Singapore in 2002 to that in 2006?
Ensure brevity in your answer.  1.22. What is the ratio of the Unemployed and educated male labor force (% of population) in Cyprus in 2002 to that in 2007?
Keep it short and to the point. 1.17. What is the ratio of the Unemployed and educated male labor force (% of population) of Denmark in 2002 to that in 2007?
Ensure brevity in your answer.  0.75. What is the ratio of the Unemployed and educated male labor force (% of population) in Jamaica in 2002 to that in 2007?
Your answer should be compact. 0.52. What is the ratio of the Unemployed and educated male labor force (% of population) of Singapore in 2002 to that in 2007?
Provide a short and direct response. 1.28. What is the ratio of the Unemployed and educated male labor force (% of population) in Cyprus in 2003 to that in 2004?
Provide a succinct answer. 0.83. What is the ratio of the Unemployed and educated male labor force (% of population) of Denmark in 2003 to that in 2004?
Provide a succinct answer. 1.23. What is the ratio of the Unemployed and educated male labor force (% of population) in Jamaica in 2003 to that in 2004?
Your response must be concise. 0.65. What is the ratio of the Unemployed and educated male labor force (% of population) in Singapore in 2003 to that in 2004?
Ensure brevity in your answer.  1.07. What is the ratio of the Unemployed and educated male labor force (% of population) in Cyprus in 2003 to that in 2006?
Offer a terse response. 1.14. What is the ratio of the Unemployed and educated male labor force (% of population) in Denmark in 2003 to that in 2006?
Provide a succinct answer. 0.97. What is the ratio of the Unemployed and educated male labor force (% of population) of Jamaica in 2003 to that in 2006?
Offer a terse response. 1.1. What is the ratio of the Unemployed and educated male labor force (% of population) in Singapore in 2003 to that in 2006?
Keep it short and to the point. 1.14. What is the ratio of the Unemployed and educated male labor force (% of population) of Cyprus in 2003 to that in 2007?
Your response must be concise. 1.17. What is the ratio of the Unemployed and educated male labor force (% of population) of Denmark in 2003 to that in 2007?
Your answer should be compact. 0.79. What is the ratio of the Unemployed and educated male labor force (% of population) of Jamaica in 2003 to that in 2007?
Provide a short and direct response. 0.63. What is the ratio of the Unemployed and educated male labor force (% of population) in Singapore in 2003 to that in 2007?
Offer a very short reply. 1.19. What is the ratio of the Unemployed and educated male labor force (% of population) in Cyprus in 2004 to that in 2006?
Keep it short and to the point. 1.37. What is the ratio of the Unemployed and educated male labor force (% of population) of Denmark in 2004 to that in 2006?
Keep it short and to the point. 0.79. What is the ratio of the Unemployed and educated male labor force (% of population) in Jamaica in 2004 to that in 2006?
Offer a very short reply. 1.69. What is the ratio of the Unemployed and educated male labor force (% of population) of Singapore in 2004 to that in 2006?
Offer a terse response. 1.07. What is the ratio of the Unemployed and educated male labor force (% of population) of Cyprus in 2004 to that in 2007?
Make the answer very short. 1.41. What is the ratio of the Unemployed and educated male labor force (% of population) of Denmark in 2004 to that in 2007?
Offer a terse response. 0.64. What is the ratio of the Unemployed and educated male labor force (% of population) in Singapore in 2004 to that in 2007?
Your answer should be very brief. 1.11. What is the ratio of the Unemployed and educated male labor force (% of population) in Cyprus in 2006 to that in 2007?
Ensure brevity in your answer.  1.02. What is the ratio of the Unemployed and educated male labor force (% of population) in Denmark in 2006 to that in 2007?
Ensure brevity in your answer.  0.81. What is the ratio of the Unemployed and educated male labor force (% of population) in Jamaica in 2006 to that in 2007?
Your answer should be very brief. 0.57. What is the ratio of the Unemployed and educated male labor force (% of population) in Singapore in 2006 to that in 2007?
Keep it short and to the point. 1.04. What is the difference between the highest and the second highest Unemployed and educated male labor force (% of population) of Denmark?
Give a very brief answer. 7.7. What is the difference between the highest and the lowest Unemployed and educated male labor force (% of population) of Cyprus?
Offer a very short reply. 11.6. What is the difference between the highest and the lowest Unemployed and educated male labor force (% of population) of Denmark?
Your answer should be very brief. 23.9. What is the difference between the highest and the lowest Unemployed and educated male labor force (% of population) of Singapore?
Your answer should be very brief. 22.3. 